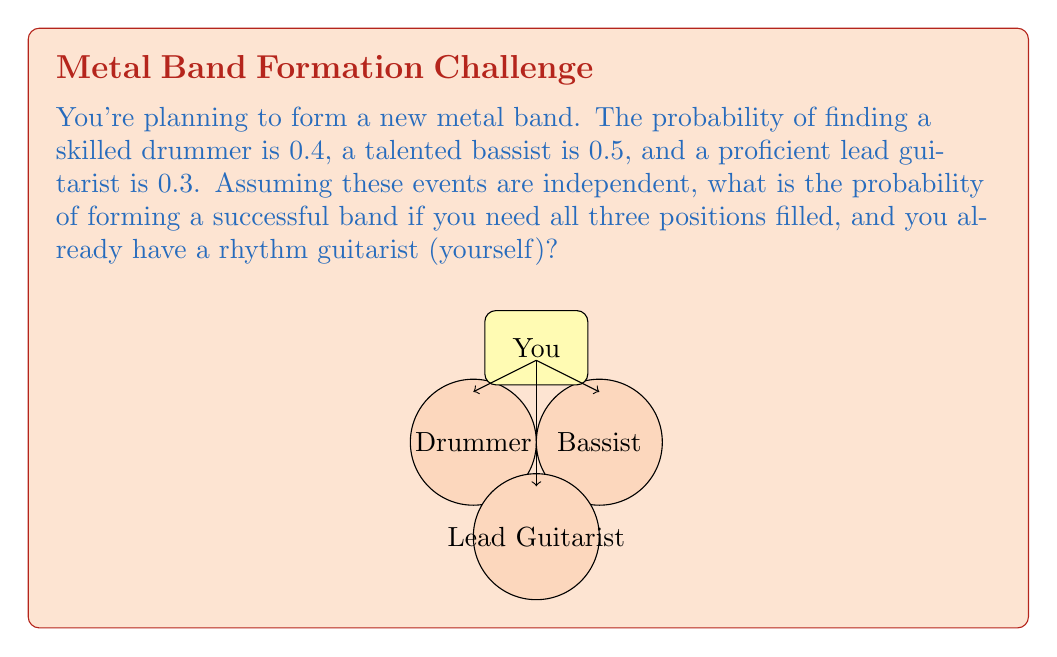What is the answer to this math problem? Let's approach this step-by-step using conditional probability:

1) Define the events:
   D: Finding a skilled drummer
   B: Finding a talented bassist
   L: Finding a proficient lead guitarist

2) Given probabilities:
   P(D) = 0.4
   P(B) = 0.5
   P(L) = 0.3

3) We need all three events to occur simultaneously. Since the events are independent, we can multiply their individual probabilities:

   $$P(\text{Successful Band}) = P(D \cap B \cap L)$$
   $$= P(D) \times P(B) \times P(L)$$

4) Substituting the values:
   $$P(\text{Successful Band}) = 0.4 \times 0.5 \times 0.3$$

5) Calculate:
   $$P(\text{Successful Band}) = 0.06$$

6) Convert to percentage:
   $$0.06 \times 100\% = 6\%$$

Therefore, the probability of forming a successful band with all required positions filled is 6%.
Answer: 6% 